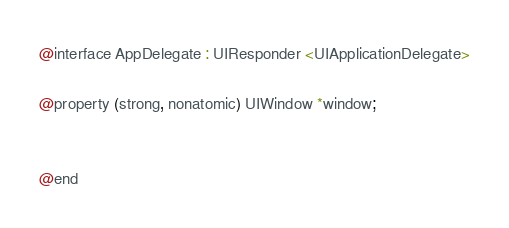<code> <loc_0><loc_0><loc_500><loc_500><_C_>
@interface AppDelegate : UIResponder <UIApplicationDelegate>

@property (strong, nonatomic) UIWindow *window;


@end

</code> 